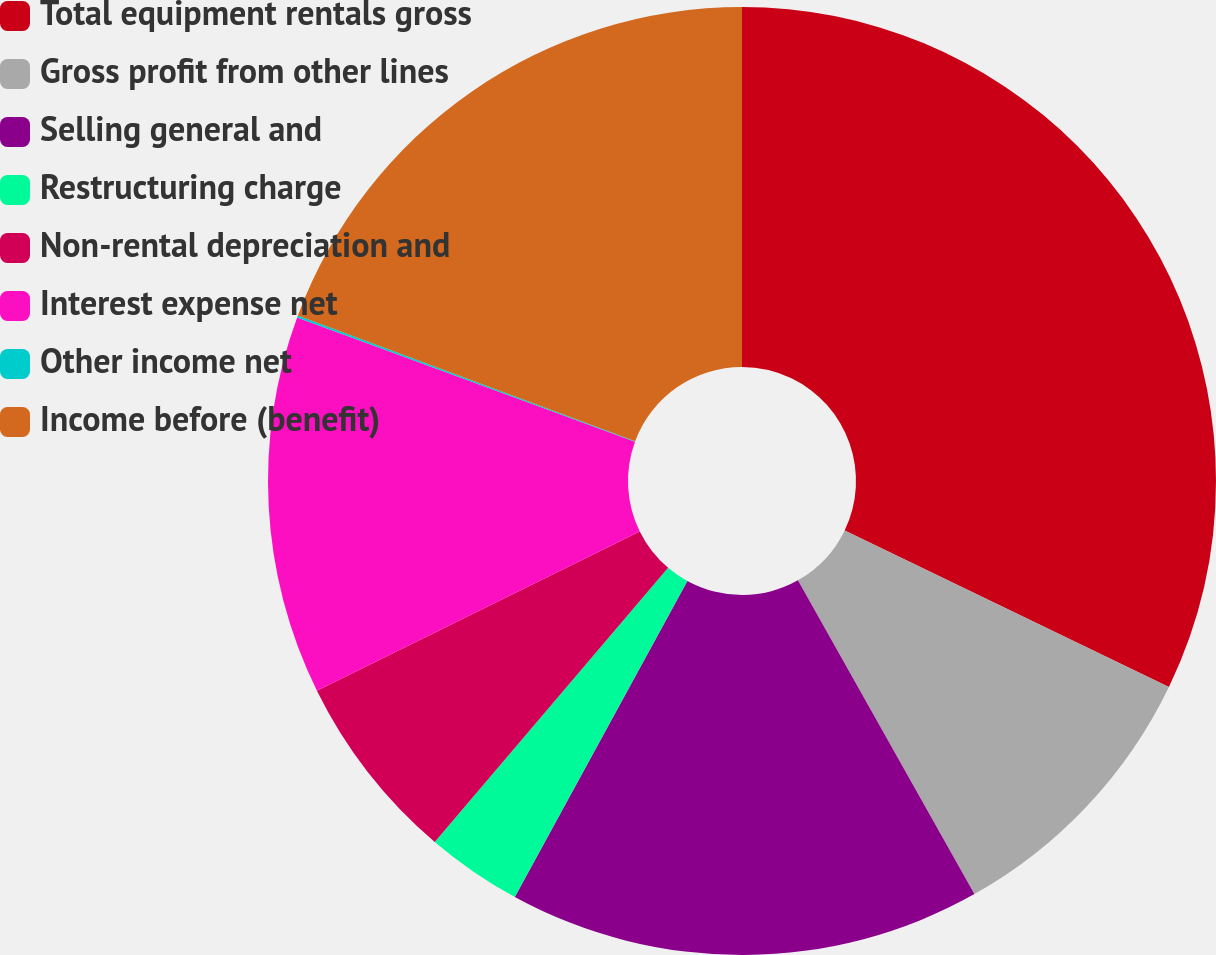<chart> <loc_0><loc_0><loc_500><loc_500><pie_chart><fcel>Total equipment rentals gross<fcel>Gross profit from other lines<fcel>Selling general and<fcel>Restructuring charge<fcel>Non-rental depreciation and<fcel>Interest expense net<fcel>Other income net<fcel>Income before (benefit)<nl><fcel>32.15%<fcel>9.69%<fcel>16.11%<fcel>3.27%<fcel>6.48%<fcel>12.9%<fcel>0.07%<fcel>19.32%<nl></chart> 